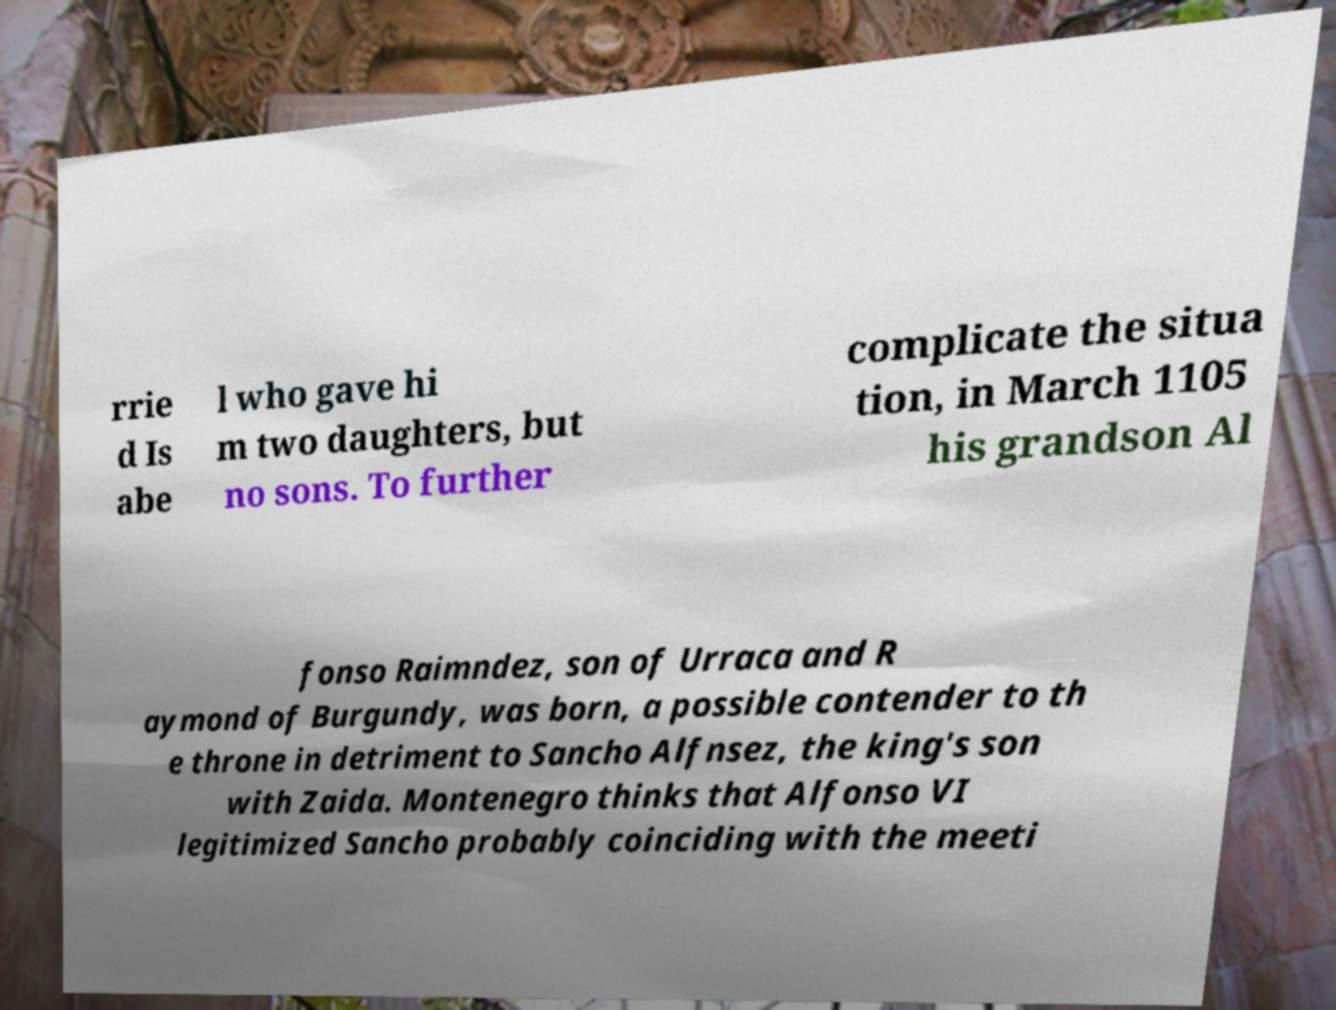Please identify and transcribe the text found in this image. rrie d Is abe l who gave hi m two daughters, but no sons. To further complicate the situa tion, in March 1105 his grandson Al fonso Raimndez, son of Urraca and R aymond of Burgundy, was born, a possible contender to th e throne in detriment to Sancho Alfnsez, the king's son with Zaida. Montenegro thinks that Alfonso VI legitimized Sancho probably coinciding with the meeti 